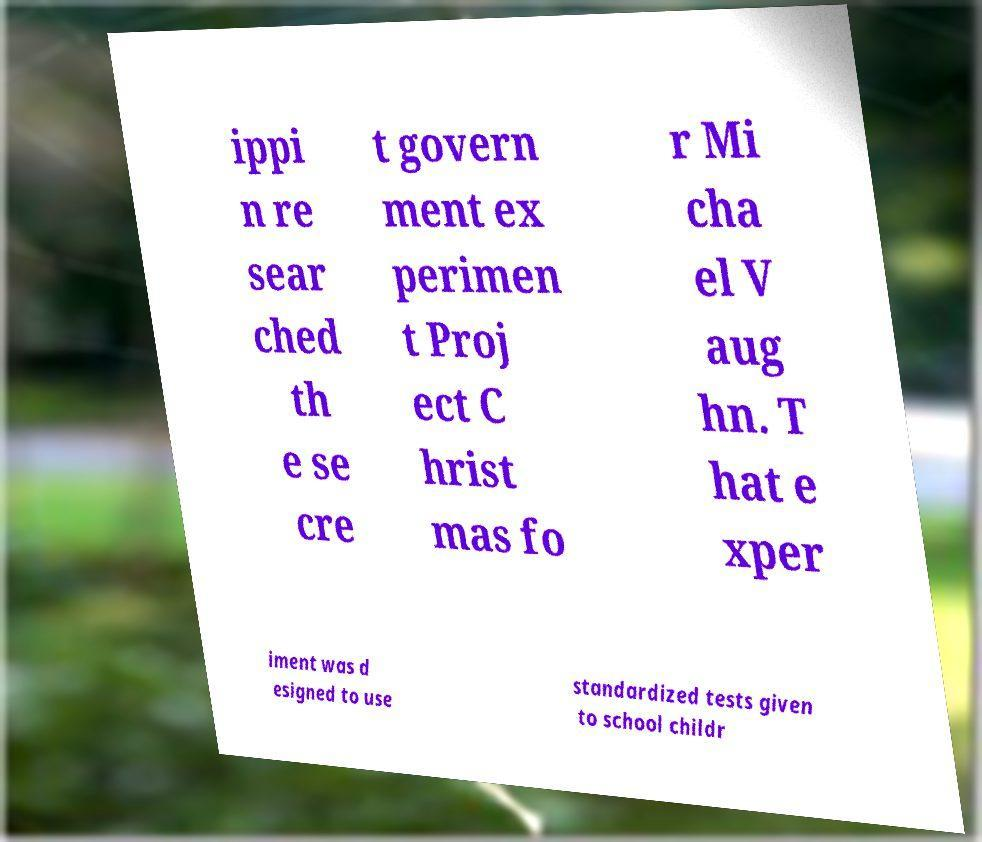Please identify and transcribe the text found in this image. ippi n re sear ched th e se cre t govern ment ex perimen t Proj ect C hrist mas fo r Mi cha el V aug hn. T hat e xper iment was d esigned to use standardized tests given to school childr 